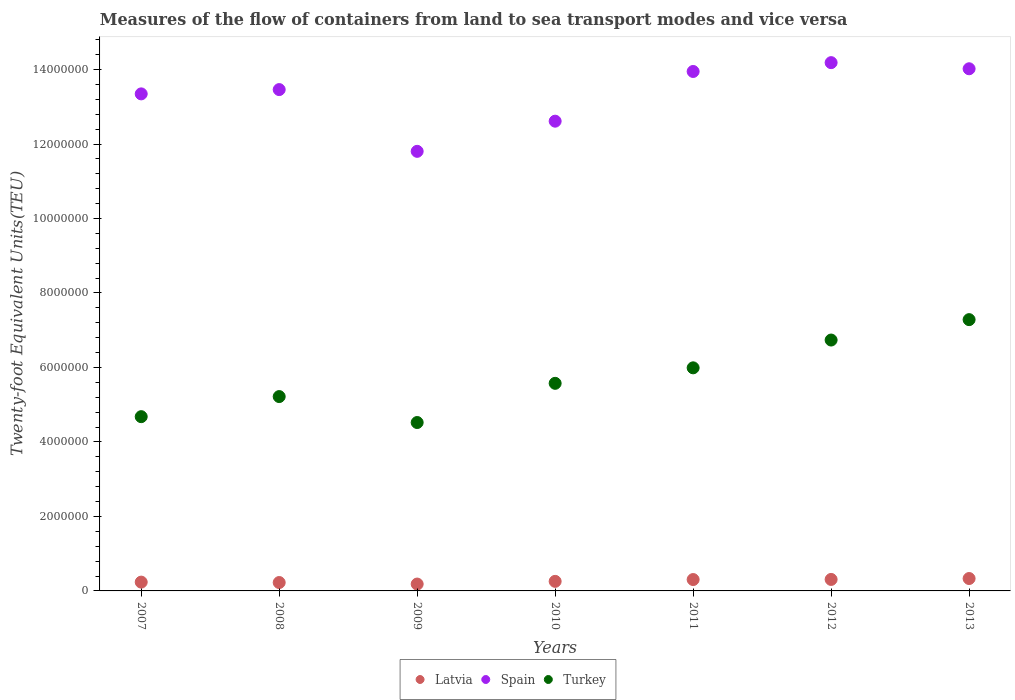What is the container port traffic in Latvia in 2011?
Ensure brevity in your answer.  3.05e+05. Across all years, what is the maximum container port traffic in Latvia?
Ensure brevity in your answer.  3.33e+05. Across all years, what is the minimum container port traffic in Spain?
Provide a succinct answer. 1.18e+07. In which year was the container port traffic in Turkey maximum?
Make the answer very short. 2013. What is the total container port traffic in Latvia in the graph?
Your answer should be compact. 1.85e+06. What is the difference between the container port traffic in Spain in 2007 and that in 2011?
Keep it short and to the point. -6.01e+05. What is the difference between the container port traffic in Turkey in 2009 and the container port traffic in Spain in 2007?
Offer a terse response. -8.82e+06. What is the average container port traffic in Spain per year?
Provide a short and direct response. 1.33e+07. In the year 2009, what is the difference between the container port traffic in Turkey and container port traffic in Latvia?
Keep it short and to the point. 4.34e+06. What is the ratio of the container port traffic in Turkey in 2007 to that in 2010?
Ensure brevity in your answer.  0.84. Is the container port traffic in Spain in 2007 less than that in 2013?
Give a very brief answer. Yes. What is the difference between the highest and the second highest container port traffic in Turkey?
Make the answer very short. 5.48e+05. What is the difference between the highest and the lowest container port traffic in Latvia?
Give a very brief answer. 1.48e+05. Is the sum of the container port traffic in Spain in 2008 and 2010 greater than the maximum container port traffic in Latvia across all years?
Your response must be concise. Yes. Is it the case that in every year, the sum of the container port traffic in Turkey and container port traffic in Latvia  is greater than the container port traffic in Spain?
Your response must be concise. No. Is the container port traffic in Turkey strictly greater than the container port traffic in Latvia over the years?
Your answer should be very brief. Yes. Is the container port traffic in Turkey strictly less than the container port traffic in Spain over the years?
Provide a short and direct response. Yes. How many years are there in the graph?
Ensure brevity in your answer.  7. What is the difference between two consecutive major ticks on the Y-axis?
Ensure brevity in your answer.  2.00e+06. Does the graph contain any zero values?
Your answer should be compact. No. Does the graph contain grids?
Your answer should be very brief. No. Where does the legend appear in the graph?
Keep it short and to the point. Bottom center. How many legend labels are there?
Your answer should be very brief. 3. What is the title of the graph?
Ensure brevity in your answer.  Measures of the flow of containers from land to sea transport modes and vice versa. What is the label or title of the Y-axis?
Offer a very short reply. Twenty-foot Equivalent Units(TEU). What is the Twenty-foot Equivalent Units(TEU) in Latvia in 2007?
Offer a terse response. 2.36e+05. What is the Twenty-foot Equivalent Units(TEU) in Spain in 2007?
Offer a terse response. 1.33e+07. What is the Twenty-foot Equivalent Units(TEU) of Turkey in 2007?
Provide a short and direct response. 4.68e+06. What is the Twenty-foot Equivalent Units(TEU) in Latvia in 2008?
Give a very brief answer. 2.25e+05. What is the Twenty-foot Equivalent Units(TEU) of Spain in 2008?
Provide a short and direct response. 1.35e+07. What is the Twenty-foot Equivalent Units(TEU) in Turkey in 2008?
Offer a terse response. 5.22e+06. What is the Twenty-foot Equivalent Units(TEU) in Latvia in 2009?
Your response must be concise. 1.84e+05. What is the Twenty-foot Equivalent Units(TEU) in Spain in 2009?
Your answer should be compact. 1.18e+07. What is the Twenty-foot Equivalent Units(TEU) in Turkey in 2009?
Your answer should be compact. 4.52e+06. What is the Twenty-foot Equivalent Units(TEU) of Latvia in 2010?
Make the answer very short. 2.57e+05. What is the Twenty-foot Equivalent Units(TEU) in Spain in 2010?
Offer a very short reply. 1.26e+07. What is the Twenty-foot Equivalent Units(TEU) in Turkey in 2010?
Your answer should be compact. 5.57e+06. What is the Twenty-foot Equivalent Units(TEU) in Latvia in 2011?
Offer a very short reply. 3.05e+05. What is the Twenty-foot Equivalent Units(TEU) of Spain in 2011?
Your response must be concise. 1.39e+07. What is the Twenty-foot Equivalent Units(TEU) of Turkey in 2011?
Offer a very short reply. 5.99e+06. What is the Twenty-foot Equivalent Units(TEU) of Latvia in 2012?
Make the answer very short. 3.08e+05. What is the Twenty-foot Equivalent Units(TEU) in Spain in 2012?
Give a very brief answer. 1.42e+07. What is the Twenty-foot Equivalent Units(TEU) of Turkey in 2012?
Your response must be concise. 6.74e+06. What is the Twenty-foot Equivalent Units(TEU) in Latvia in 2013?
Give a very brief answer. 3.33e+05. What is the Twenty-foot Equivalent Units(TEU) in Spain in 2013?
Provide a short and direct response. 1.40e+07. What is the Twenty-foot Equivalent Units(TEU) of Turkey in 2013?
Provide a succinct answer. 7.28e+06. Across all years, what is the maximum Twenty-foot Equivalent Units(TEU) of Latvia?
Your answer should be very brief. 3.33e+05. Across all years, what is the maximum Twenty-foot Equivalent Units(TEU) in Spain?
Provide a short and direct response. 1.42e+07. Across all years, what is the maximum Twenty-foot Equivalent Units(TEU) in Turkey?
Provide a short and direct response. 7.28e+06. Across all years, what is the minimum Twenty-foot Equivalent Units(TEU) of Latvia?
Offer a terse response. 1.84e+05. Across all years, what is the minimum Twenty-foot Equivalent Units(TEU) in Spain?
Ensure brevity in your answer.  1.18e+07. Across all years, what is the minimum Twenty-foot Equivalent Units(TEU) in Turkey?
Ensure brevity in your answer.  4.52e+06. What is the total Twenty-foot Equivalent Units(TEU) in Latvia in the graph?
Your answer should be compact. 1.85e+06. What is the total Twenty-foot Equivalent Units(TEU) of Spain in the graph?
Provide a succinct answer. 9.34e+07. What is the total Twenty-foot Equivalent Units(TEU) in Turkey in the graph?
Your response must be concise. 4.00e+07. What is the difference between the Twenty-foot Equivalent Units(TEU) of Latvia in 2007 and that in 2008?
Offer a terse response. 1.09e+04. What is the difference between the Twenty-foot Equivalent Units(TEU) of Spain in 2007 and that in 2008?
Offer a terse response. -1.15e+05. What is the difference between the Twenty-foot Equivalent Units(TEU) in Turkey in 2007 and that in 2008?
Make the answer very short. -5.39e+05. What is the difference between the Twenty-foot Equivalent Units(TEU) of Latvia in 2007 and that in 2009?
Ensure brevity in your answer.  5.20e+04. What is the difference between the Twenty-foot Equivalent Units(TEU) of Spain in 2007 and that in 2009?
Keep it short and to the point. 1.54e+06. What is the difference between the Twenty-foot Equivalent Units(TEU) in Turkey in 2007 and that in 2009?
Give a very brief answer. 1.57e+05. What is the difference between the Twenty-foot Equivalent Units(TEU) of Latvia in 2007 and that in 2010?
Your answer should be very brief. -2.04e+04. What is the difference between the Twenty-foot Equivalent Units(TEU) in Spain in 2007 and that in 2010?
Your response must be concise. 7.33e+05. What is the difference between the Twenty-foot Equivalent Units(TEU) in Turkey in 2007 and that in 2010?
Your response must be concise. -8.95e+05. What is the difference between the Twenty-foot Equivalent Units(TEU) of Latvia in 2007 and that in 2011?
Ensure brevity in your answer.  -6.90e+04. What is the difference between the Twenty-foot Equivalent Units(TEU) of Spain in 2007 and that in 2011?
Provide a succinct answer. -6.01e+05. What is the difference between the Twenty-foot Equivalent Units(TEU) in Turkey in 2007 and that in 2011?
Offer a terse response. -1.31e+06. What is the difference between the Twenty-foot Equivalent Units(TEU) in Latvia in 2007 and that in 2012?
Ensure brevity in your answer.  -7.21e+04. What is the difference between the Twenty-foot Equivalent Units(TEU) in Spain in 2007 and that in 2012?
Offer a terse response. -8.39e+05. What is the difference between the Twenty-foot Equivalent Units(TEU) in Turkey in 2007 and that in 2012?
Your response must be concise. -2.06e+06. What is the difference between the Twenty-foot Equivalent Units(TEU) in Latvia in 2007 and that in 2013?
Keep it short and to the point. -9.64e+04. What is the difference between the Twenty-foot Equivalent Units(TEU) of Spain in 2007 and that in 2013?
Give a very brief answer. -6.74e+05. What is the difference between the Twenty-foot Equivalent Units(TEU) of Turkey in 2007 and that in 2013?
Your response must be concise. -2.61e+06. What is the difference between the Twenty-foot Equivalent Units(TEU) in Latvia in 2008 and that in 2009?
Provide a succinct answer. 4.11e+04. What is the difference between the Twenty-foot Equivalent Units(TEU) of Spain in 2008 and that in 2009?
Give a very brief answer. 1.66e+06. What is the difference between the Twenty-foot Equivalent Units(TEU) in Turkey in 2008 and that in 2009?
Make the answer very short. 6.97e+05. What is the difference between the Twenty-foot Equivalent Units(TEU) in Latvia in 2008 and that in 2010?
Your answer should be compact. -3.12e+04. What is the difference between the Twenty-foot Equivalent Units(TEU) in Spain in 2008 and that in 2010?
Make the answer very short. 8.48e+05. What is the difference between the Twenty-foot Equivalent Units(TEU) of Turkey in 2008 and that in 2010?
Keep it short and to the point. -3.56e+05. What is the difference between the Twenty-foot Equivalent Units(TEU) in Latvia in 2008 and that in 2011?
Your response must be concise. -7.99e+04. What is the difference between the Twenty-foot Equivalent Units(TEU) in Spain in 2008 and that in 2011?
Your answer should be very brief. -4.86e+05. What is the difference between the Twenty-foot Equivalent Units(TEU) in Turkey in 2008 and that in 2011?
Provide a short and direct response. -7.72e+05. What is the difference between the Twenty-foot Equivalent Units(TEU) in Latvia in 2008 and that in 2012?
Offer a terse response. -8.30e+04. What is the difference between the Twenty-foot Equivalent Units(TEU) of Spain in 2008 and that in 2012?
Offer a terse response. -7.23e+05. What is the difference between the Twenty-foot Equivalent Units(TEU) in Turkey in 2008 and that in 2012?
Ensure brevity in your answer.  -1.52e+06. What is the difference between the Twenty-foot Equivalent Units(TEU) of Latvia in 2008 and that in 2013?
Your answer should be compact. -1.07e+05. What is the difference between the Twenty-foot Equivalent Units(TEU) of Spain in 2008 and that in 2013?
Your answer should be very brief. -5.59e+05. What is the difference between the Twenty-foot Equivalent Units(TEU) in Turkey in 2008 and that in 2013?
Keep it short and to the point. -2.07e+06. What is the difference between the Twenty-foot Equivalent Units(TEU) in Latvia in 2009 and that in 2010?
Provide a short and direct response. -7.23e+04. What is the difference between the Twenty-foot Equivalent Units(TEU) in Spain in 2009 and that in 2010?
Keep it short and to the point. -8.10e+05. What is the difference between the Twenty-foot Equivalent Units(TEU) in Turkey in 2009 and that in 2010?
Give a very brief answer. -1.05e+06. What is the difference between the Twenty-foot Equivalent Units(TEU) of Latvia in 2009 and that in 2011?
Ensure brevity in your answer.  -1.21e+05. What is the difference between the Twenty-foot Equivalent Units(TEU) of Spain in 2009 and that in 2011?
Provide a succinct answer. -2.14e+06. What is the difference between the Twenty-foot Equivalent Units(TEU) of Turkey in 2009 and that in 2011?
Offer a very short reply. -1.47e+06. What is the difference between the Twenty-foot Equivalent Units(TEU) of Latvia in 2009 and that in 2012?
Your answer should be compact. -1.24e+05. What is the difference between the Twenty-foot Equivalent Units(TEU) in Spain in 2009 and that in 2012?
Provide a short and direct response. -2.38e+06. What is the difference between the Twenty-foot Equivalent Units(TEU) in Turkey in 2009 and that in 2012?
Provide a succinct answer. -2.21e+06. What is the difference between the Twenty-foot Equivalent Units(TEU) of Latvia in 2009 and that in 2013?
Keep it short and to the point. -1.48e+05. What is the difference between the Twenty-foot Equivalent Units(TEU) in Spain in 2009 and that in 2013?
Keep it short and to the point. -2.22e+06. What is the difference between the Twenty-foot Equivalent Units(TEU) of Turkey in 2009 and that in 2013?
Ensure brevity in your answer.  -2.76e+06. What is the difference between the Twenty-foot Equivalent Units(TEU) of Latvia in 2010 and that in 2011?
Provide a succinct answer. -4.86e+04. What is the difference between the Twenty-foot Equivalent Units(TEU) of Spain in 2010 and that in 2011?
Your response must be concise. -1.33e+06. What is the difference between the Twenty-foot Equivalent Units(TEU) in Turkey in 2010 and that in 2011?
Offer a terse response. -4.16e+05. What is the difference between the Twenty-foot Equivalent Units(TEU) of Latvia in 2010 and that in 2012?
Make the answer very short. -5.17e+04. What is the difference between the Twenty-foot Equivalent Units(TEU) in Spain in 2010 and that in 2012?
Ensure brevity in your answer.  -1.57e+06. What is the difference between the Twenty-foot Equivalent Units(TEU) of Turkey in 2010 and that in 2012?
Your answer should be very brief. -1.16e+06. What is the difference between the Twenty-foot Equivalent Units(TEU) in Latvia in 2010 and that in 2013?
Provide a succinct answer. -7.61e+04. What is the difference between the Twenty-foot Equivalent Units(TEU) in Spain in 2010 and that in 2013?
Provide a succinct answer. -1.41e+06. What is the difference between the Twenty-foot Equivalent Units(TEU) of Turkey in 2010 and that in 2013?
Make the answer very short. -1.71e+06. What is the difference between the Twenty-foot Equivalent Units(TEU) in Latvia in 2011 and that in 2012?
Keep it short and to the point. -3086.24. What is the difference between the Twenty-foot Equivalent Units(TEU) in Spain in 2011 and that in 2012?
Offer a terse response. -2.37e+05. What is the difference between the Twenty-foot Equivalent Units(TEU) in Turkey in 2011 and that in 2012?
Make the answer very short. -7.46e+05. What is the difference between the Twenty-foot Equivalent Units(TEU) in Latvia in 2011 and that in 2013?
Your answer should be compact. -2.75e+04. What is the difference between the Twenty-foot Equivalent Units(TEU) of Spain in 2011 and that in 2013?
Give a very brief answer. -7.27e+04. What is the difference between the Twenty-foot Equivalent Units(TEU) in Turkey in 2011 and that in 2013?
Provide a short and direct response. -1.29e+06. What is the difference between the Twenty-foot Equivalent Units(TEU) in Latvia in 2012 and that in 2013?
Your answer should be compact. -2.44e+04. What is the difference between the Twenty-foot Equivalent Units(TEU) of Spain in 2012 and that in 2013?
Make the answer very short. 1.65e+05. What is the difference between the Twenty-foot Equivalent Units(TEU) in Turkey in 2012 and that in 2013?
Your response must be concise. -5.48e+05. What is the difference between the Twenty-foot Equivalent Units(TEU) of Latvia in 2007 and the Twenty-foot Equivalent Units(TEU) of Spain in 2008?
Your response must be concise. -1.32e+07. What is the difference between the Twenty-foot Equivalent Units(TEU) of Latvia in 2007 and the Twenty-foot Equivalent Units(TEU) of Turkey in 2008?
Your answer should be very brief. -4.98e+06. What is the difference between the Twenty-foot Equivalent Units(TEU) of Spain in 2007 and the Twenty-foot Equivalent Units(TEU) of Turkey in 2008?
Offer a terse response. 8.13e+06. What is the difference between the Twenty-foot Equivalent Units(TEU) of Latvia in 2007 and the Twenty-foot Equivalent Units(TEU) of Spain in 2009?
Provide a short and direct response. -1.16e+07. What is the difference between the Twenty-foot Equivalent Units(TEU) in Latvia in 2007 and the Twenty-foot Equivalent Units(TEU) in Turkey in 2009?
Ensure brevity in your answer.  -4.29e+06. What is the difference between the Twenty-foot Equivalent Units(TEU) of Spain in 2007 and the Twenty-foot Equivalent Units(TEU) of Turkey in 2009?
Provide a short and direct response. 8.82e+06. What is the difference between the Twenty-foot Equivalent Units(TEU) of Latvia in 2007 and the Twenty-foot Equivalent Units(TEU) of Spain in 2010?
Keep it short and to the point. -1.24e+07. What is the difference between the Twenty-foot Equivalent Units(TEU) in Latvia in 2007 and the Twenty-foot Equivalent Units(TEU) in Turkey in 2010?
Offer a terse response. -5.34e+06. What is the difference between the Twenty-foot Equivalent Units(TEU) in Spain in 2007 and the Twenty-foot Equivalent Units(TEU) in Turkey in 2010?
Make the answer very short. 7.77e+06. What is the difference between the Twenty-foot Equivalent Units(TEU) in Latvia in 2007 and the Twenty-foot Equivalent Units(TEU) in Spain in 2011?
Offer a terse response. -1.37e+07. What is the difference between the Twenty-foot Equivalent Units(TEU) of Latvia in 2007 and the Twenty-foot Equivalent Units(TEU) of Turkey in 2011?
Offer a very short reply. -5.75e+06. What is the difference between the Twenty-foot Equivalent Units(TEU) of Spain in 2007 and the Twenty-foot Equivalent Units(TEU) of Turkey in 2011?
Offer a very short reply. 7.36e+06. What is the difference between the Twenty-foot Equivalent Units(TEU) in Latvia in 2007 and the Twenty-foot Equivalent Units(TEU) in Spain in 2012?
Provide a short and direct response. -1.39e+07. What is the difference between the Twenty-foot Equivalent Units(TEU) of Latvia in 2007 and the Twenty-foot Equivalent Units(TEU) of Turkey in 2012?
Your answer should be very brief. -6.50e+06. What is the difference between the Twenty-foot Equivalent Units(TEU) in Spain in 2007 and the Twenty-foot Equivalent Units(TEU) in Turkey in 2012?
Give a very brief answer. 6.61e+06. What is the difference between the Twenty-foot Equivalent Units(TEU) of Latvia in 2007 and the Twenty-foot Equivalent Units(TEU) of Spain in 2013?
Your answer should be very brief. -1.38e+07. What is the difference between the Twenty-foot Equivalent Units(TEU) in Latvia in 2007 and the Twenty-foot Equivalent Units(TEU) in Turkey in 2013?
Ensure brevity in your answer.  -7.05e+06. What is the difference between the Twenty-foot Equivalent Units(TEU) of Spain in 2007 and the Twenty-foot Equivalent Units(TEU) of Turkey in 2013?
Give a very brief answer. 6.06e+06. What is the difference between the Twenty-foot Equivalent Units(TEU) of Latvia in 2008 and the Twenty-foot Equivalent Units(TEU) of Spain in 2009?
Ensure brevity in your answer.  -1.16e+07. What is the difference between the Twenty-foot Equivalent Units(TEU) in Latvia in 2008 and the Twenty-foot Equivalent Units(TEU) in Turkey in 2009?
Provide a short and direct response. -4.30e+06. What is the difference between the Twenty-foot Equivalent Units(TEU) of Spain in 2008 and the Twenty-foot Equivalent Units(TEU) of Turkey in 2009?
Provide a succinct answer. 8.94e+06. What is the difference between the Twenty-foot Equivalent Units(TEU) in Latvia in 2008 and the Twenty-foot Equivalent Units(TEU) in Spain in 2010?
Offer a terse response. -1.24e+07. What is the difference between the Twenty-foot Equivalent Units(TEU) in Latvia in 2008 and the Twenty-foot Equivalent Units(TEU) in Turkey in 2010?
Provide a short and direct response. -5.35e+06. What is the difference between the Twenty-foot Equivalent Units(TEU) of Spain in 2008 and the Twenty-foot Equivalent Units(TEU) of Turkey in 2010?
Offer a very short reply. 7.89e+06. What is the difference between the Twenty-foot Equivalent Units(TEU) in Latvia in 2008 and the Twenty-foot Equivalent Units(TEU) in Spain in 2011?
Ensure brevity in your answer.  -1.37e+07. What is the difference between the Twenty-foot Equivalent Units(TEU) in Latvia in 2008 and the Twenty-foot Equivalent Units(TEU) in Turkey in 2011?
Make the answer very short. -5.76e+06. What is the difference between the Twenty-foot Equivalent Units(TEU) in Spain in 2008 and the Twenty-foot Equivalent Units(TEU) in Turkey in 2011?
Give a very brief answer. 7.47e+06. What is the difference between the Twenty-foot Equivalent Units(TEU) in Latvia in 2008 and the Twenty-foot Equivalent Units(TEU) in Spain in 2012?
Provide a succinct answer. -1.40e+07. What is the difference between the Twenty-foot Equivalent Units(TEU) of Latvia in 2008 and the Twenty-foot Equivalent Units(TEU) of Turkey in 2012?
Your answer should be very brief. -6.51e+06. What is the difference between the Twenty-foot Equivalent Units(TEU) of Spain in 2008 and the Twenty-foot Equivalent Units(TEU) of Turkey in 2012?
Your answer should be compact. 6.72e+06. What is the difference between the Twenty-foot Equivalent Units(TEU) of Latvia in 2008 and the Twenty-foot Equivalent Units(TEU) of Spain in 2013?
Make the answer very short. -1.38e+07. What is the difference between the Twenty-foot Equivalent Units(TEU) of Latvia in 2008 and the Twenty-foot Equivalent Units(TEU) of Turkey in 2013?
Provide a short and direct response. -7.06e+06. What is the difference between the Twenty-foot Equivalent Units(TEU) in Spain in 2008 and the Twenty-foot Equivalent Units(TEU) in Turkey in 2013?
Keep it short and to the point. 6.18e+06. What is the difference between the Twenty-foot Equivalent Units(TEU) in Latvia in 2009 and the Twenty-foot Equivalent Units(TEU) in Spain in 2010?
Offer a terse response. -1.24e+07. What is the difference between the Twenty-foot Equivalent Units(TEU) of Latvia in 2009 and the Twenty-foot Equivalent Units(TEU) of Turkey in 2010?
Make the answer very short. -5.39e+06. What is the difference between the Twenty-foot Equivalent Units(TEU) in Spain in 2009 and the Twenty-foot Equivalent Units(TEU) in Turkey in 2010?
Give a very brief answer. 6.23e+06. What is the difference between the Twenty-foot Equivalent Units(TEU) of Latvia in 2009 and the Twenty-foot Equivalent Units(TEU) of Spain in 2011?
Your answer should be very brief. -1.38e+07. What is the difference between the Twenty-foot Equivalent Units(TEU) of Latvia in 2009 and the Twenty-foot Equivalent Units(TEU) of Turkey in 2011?
Your answer should be compact. -5.81e+06. What is the difference between the Twenty-foot Equivalent Units(TEU) in Spain in 2009 and the Twenty-foot Equivalent Units(TEU) in Turkey in 2011?
Give a very brief answer. 5.81e+06. What is the difference between the Twenty-foot Equivalent Units(TEU) in Latvia in 2009 and the Twenty-foot Equivalent Units(TEU) in Spain in 2012?
Keep it short and to the point. -1.40e+07. What is the difference between the Twenty-foot Equivalent Units(TEU) of Latvia in 2009 and the Twenty-foot Equivalent Units(TEU) of Turkey in 2012?
Make the answer very short. -6.55e+06. What is the difference between the Twenty-foot Equivalent Units(TEU) in Spain in 2009 and the Twenty-foot Equivalent Units(TEU) in Turkey in 2012?
Keep it short and to the point. 5.07e+06. What is the difference between the Twenty-foot Equivalent Units(TEU) of Latvia in 2009 and the Twenty-foot Equivalent Units(TEU) of Spain in 2013?
Your answer should be compact. -1.38e+07. What is the difference between the Twenty-foot Equivalent Units(TEU) of Latvia in 2009 and the Twenty-foot Equivalent Units(TEU) of Turkey in 2013?
Offer a very short reply. -7.10e+06. What is the difference between the Twenty-foot Equivalent Units(TEU) in Spain in 2009 and the Twenty-foot Equivalent Units(TEU) in Turkey in 2013?
Give a very brief answer. 4.52e+06. What is the difference between the Twenty-foot Equivalent Units(TEU) in Latvia in 2010 and the Twenty-foot Equivalent Units(TEU) in Spain in 2011?
Ensure brevity in your answer.  -1.37e+07. What is the difference between the Twenty-foot Equivalent Units(TEU) in Latvia in 2010 and the Twenty-foot Equivalent Units(TEU) in Turkey in 2011?
Offer a terse response. -5.73e+06. What is the difference between the Twenty-foot Equivalent Units(TEU) of Spain in 2010 and the Twenty-foot Equivalent Units(TEU) of Turkey in 2011?
Offer a very short reply. 6.62e+06. What is the difference between the Twenty-foot Equivalent Units(TEU) in Latvia in 2010 and the Twenty-foot Equivalent Units(TEU) in Spain in 2012?
Ensure brevity in your answer.  -1.39e+07. What is the difference between the Twenty-foot Equivalent Units(TEU) of Latvia in 2010 and the Twenty-foot Equivalent Units(TEU) of Turkey in 2012?
Your response must be concise. -6.48e+06. What is the difference between the Twenty-foot Equivalent Units(TEU) in Spain in 2010 and the Twenty-foot Equivalent Units(TEU) in Turkey in 2012?
Provide a short and direct response. 5.88e+06. What is the difference between the Twenty-foot Equivalent Units(TEU) in Latvia in 2010 and the Twenty-foot Equivalent Units(TEU) in Spain in 2013?
Make the answer very short. -1.38e+07. What is the difference between the Twenty-foot Equivalent Units(TEU) of Latvia in 2010 and the Twenty-foot Equivalent Units(TEU) of Turkey in 2013?
Provide a short and direct response. -7.03e+06. What is the difference between the Twenty-foot Equivalent Units(TEU) of Spain in 2010 and the Twenty-foot Equivalent Units(TEU) of Turkey in 2013?
Provide a short and direct response. 5.33e+06. What is the difference between the Twenty-foot Equivalent Units(TEU) of Latvia in 2011 and the Twenty-foot Equivalent Units(TEU) of Spain in 2012?
Ensure brevity in your answer.  -1.39e+07. What is the difference between the Twenty-foot Equivalent Units(TEU) in Latvia in 2011 and the Twenty-foot Equivalent Units(TEU) in Turkey in 2012?
Offer a very short reply. -6.43e+06. What is the difference between the Twenty-foot Equivalent Units(TEU) of Spain in 2011 and the Twenty-foot Equivalent Units(TEU) of Turkey in 2012?
Provide a succinct answer. 7.21e+06. What is the difference between the Twenty-foot Equivalent Units(TEU) in Latvia in 2011 and the Twenty-foot Equivalent Units(TEU) in Spain in 2013?
Your answer should be very brief. -1.37e+07. What is the difference between the Twenty-foot Equivalent Units(TEU) in Latvia in 2011 and the Twenty-foot Equivalent Units(TEU) in Turkey in 2013?
Provide a succinct answer. -6.98e+06. What is the difference between the Twenty-foot Equivalent Units(TEU) of Spain in 2011 and the Twenty-foot Equivalent Units(TEU) of Turkey in 2013?
Give a very brief answer. 6.66e+06. What is the difference between the Twenty-foot Equivalent Units(TEU) of Latvia in 2012 and the Twenty-foot Equivalent Units(TEU) of Spain in 2013?
Offer a very short reply. -1.37e+07. What is the difference between the Twenty-foot Equivalent Units(TEU) of Latvia in 2012 and the Twenty-foot Equivalent Units(TEU) of Turkey in 2013?
Your response must be concise. -6.98e+06. What is the difference between the Twenty-foot Equivalent Units(TEU) of Spain in 2012 and the Twenty-foot Equivalent Units(TEU) of Turkey in 2013?
Offer a very short reply. 6.90e+06. What is the average Twenty-foot Equivalent Units(TEU) in Latvia per year?
Provide a succinct answer. 2.64e+05. What is the average Twenty-foot Equivalent Units(TEU) of Spain per year?
Provide a succinct answer. 1.33e+07. What is the average Twenty-foot Equivalent Units(TEU) in Turkey per year?
Provide a succinct answer. 5.71e+06. In the year 2007, what is the difference between the Twenty-foot Equivalent Units(TEU) in Latvia and Twenty-foot Equivalent Units(TEU) in Spain?
Make the answer very short. -1.31e+07. In the year 2007, what is the difference between the Twenty-foot Equivalent Units(TEU) in Latvia and Twenty-foot Equivalent Units(TEU) in Turkey?
Keep it short and to the point. -4.44e+06. In the year 2007, what is the difference between the Twenty-foot Equivalent Units(TEU) of Spain and Twenty-foot Equivalent Units(TEU) of Turkey?
Provide a succinct answer. 8.67e+06. In the year 2008, what is the difference between the Twenty-foot Equivalent Units(TEU) in Latvia and Twenty-foot Equivalent Units(TEU) in Spain?
Provide a short and direct response. -1.32e+07. In the year 2008, what is the difference between the Twenty-foot Equivalent Units(TEU) of Latvia and Twenty-foot Equivalent Units(TEU) of Turkey?
Ensure brevity in your answer.  -4.99e+06. In the year 2008, what is the difference between the Twenty-foot Equivalent Units(TEU) in Spain and Twenty-foot Equivalent Units(TEU) in Turkey?
Your response must be concise. 8.24e+06. In the year 2009, what is the difference between the Twenty-foot Equivalent Units(TEU) in Latvia and Twenty-foot Equivalent Units(TEU) in Spain?
Offer a terse response. -1.16e+07. In the year 2009, what is the difference between the Twenty-foot Equivalent Units(TEU) in Latvia and Twenty-foot Equivalent Units(TEU) in Turkey?
Your answer should be very brief. -4.34e+06. In the year 2009, what is the difference between the Twenty-foot Equivalent Units(TEU) in Spain and Twenty-foot Equivalent Units(TEU) in Turkey?
Provide a succinct answer. 7.28e+06. In the year 2010, what is the difference between the Twenty-foot Equivalent Units(TEU) of Latvia and Twenty-foot Equivalent Units(TEU) of Spain?
Your answer should be very brief. -1.24e+07. In the year 2010, what is the difference between the Twenty-foot Equivalent Units(TEU) in Latvia and Twenty-foot Equivalent Units(TEU) in Turkey?
Your response must be concise. -5.32e+06. In the year 2010, what is the difference between the Twenty-foot Equivalent Units(TEU) of Spain and Twenty-foot Equivalent Units(TEU) of Turkey?
Make the answer very short. 7.04e+06. In the year 2011, what is the difference between the Twenty-foot Equivalent Units(TEU) in Latvia and Twenty-foot Equivalent Units(TEU) in Spain?
Make the answer very short. -1.36e+07. In the year 2011, what is the difference between the Twenty-foot Equivalent Units(TEU) in Latvia and Twenty-foot Equivalent Units(TEU) in Turkey?
Your answer should be very brief. -5.68e+06. In the year 2011, what is the difference between the Twenty-foot Equivalent Units(TEU) of Spain and Twenty-foot Equivalent Units(TEU) of Turkey?
Offer a terse response. 7.96e+06. In the year 2012, what is the difference between the Twenty-foot Equivalent Units(TEU) in Latvia and Twenty-foot Equivalent Units(TEU) in Spain?
Give a very brief answer. -1.39e+07. In the year 2012, what is the difference between the Twenty-foot Equivalent Units(TEU) in Latvia and Twenty-foot Equivalent Units(TEU) in Turkey?
Offer a very short reply. -6.43e+06. In the year 2012, what is the difference between the Twenty-foot Equivalent Units(TEU) of Spain and Twenty-foot Equivalent Units(TEU) of Turkey?
Ensure brevity in your answer.  7.45e+06. In the year 2013, what is the difference between the Twenty-foot Equivalent Units(TEU) in Latvia and Twenty-foot Equivalent Units(TEU) in Spain?
Give a very brief answer. -1.37e+07. In the year 2013, what is the difference between the Twenty-foot Equivalent Units(TEU) of Latvia and Twenty-foot Equivalent Units(TEU) of Turkey?
Offer a very short reply. -6.95e+06. In the year 2013, what is the difference between the Twenty-foot Equivalent Units(TEU) in Spain and Twenty-foot Equivalent Units(TEU) in Turkey?
Your response must be concise. 6.74e+06. What is the ratio of the Twenty-foot Equivalent Units(TEU) in Latvia in 2007 to that in 2008?
Your answer should be very brief. 1.05. What is the ratio of the Twenty-foot Equivalent Units(TEU) of Spain in 2007 to that in 2008?
Provide a short and direct response. 0.99. What is the ratio of the Twenty-foot Equivalent Units(TEU) of Turkey in 2007 to that in 2008?
Your answer should be compact. 0.9. What is the ratio of the Twenty-foot Equivalent Units(TEU) in Latvia in 2007 to that in 2009?
Your answer should be compact. 1.28. What is the ratio of the Twenty-foot Equivalent Units(TEU) of Spain in 2007 to that in 2009?
Offer a terse response. 1.13. What is the ratio of the Twenty-foot Equivalent Units(TEU) in Turkey in 2007 to that in 2009?
Keep it short and to the point. 1.03. What is the ratio of the Twenty-foot Equivalent Units(TEU) in Latvia in 2007 to that in 2010?
Provide a succinct answer. 0.92. What is the ratio of the Twenty-foot Equivalent Units(TEU) of Spain in 2007 to that in 2010?
Give a very brief answer. 1.06. What is the ratio of the Twenty-foot Equivalent Units(TEU) in Turkey in 2007 to that in 2010?
Offer a very short reply. 0.84. What is the ratio of the Twenty-foot Equivalent Units(TEU) of Latvia in 2007 to that in 2011?
Give a very brief answer. 0.77. What is the ratio of the Twenty-foot Equivalent Units(TEU) in Spain in 2007 to that in 2011?
Your answer should be very brief. 0.96. What is the ratio of the Twenty-foot Equivalent Units(TEU) of Turkey in 2007 to that in 2011?
Keep it short and to the point. 0.78. What is the ratio of the Twenty-foot Equivalent Units(TEU) of Latvia in 2007 to that in 2012?
Ensure brevity in your answer.  0.77. What is the ratio of the Twenty-foot Equivalent Units(TEU) in Spain in 2007 to that in 2012?
Offer a very short reply. 0.94. What is the ratio of the Twenty-foot Equivalent Units(TEU) in Turkey in 2007 to that in 2012?
Ensure brevity in your answer.  0.69. What is the ratio of the Twenty-foot Equivalent Units(TEU) in Latvia in 2007 to that in 2013?
Your answer should be compact. 0.71. What is the ratio of the Twenty-foot Equivalent Units(TEU) in Spain in 2007 to that in 2013?
Your answer should be compact. 0.95. What is the ratio of the Twenty-foot Equivalent Units(TEU) in Turkey in 2007 to that in 2013?
Your answer should be compact. 0.64. What is the ratio of the Twenty-foot Equivalent Units(TEU) of Latvia in 2008 to that in 2009?
Your answer should be compact. 1.22. What is the ratio of the Twenty-foot Equivalent Units(TEU) of Spain in 2008 to that in 2009?
Provide a succinct answer. 1.14. What is the ratio of the Twenty-foot Equivalent Units(TEU) in Turkey in 2008 to that in 2009?
Provide a succinct answer. 1.15. What is the ratio of the Twenty-foot Equivalent Units(TEU) of Latvia in 2008 to that in 2010?
Offer a terse response. 0.88. What is the ratio of the Twenty-foot Equivalent Units(TEU) in Spain in 2008 to that in 2010?
Make the answer very short. 1.07. What is the ratio of the Twenty-foot Equivalent Units(TEU) of Turkey in 2008 to that in 2010?
Ensure brevity in your answer.  0.94. What is the ratio of the Twenty-foot Equivalent Units(TEU) of Latvia in 2008 to that in 2011?
Keep it short and to the point. 0.74. What is the ratio of the Twenty-foot Equivalent Units(TEU) in Spain in 2008 to that in 2011?
Offer a very short reply. 0.97. What is the ratio of the Twenty-foot Equivalent Units(TEU) of Turkey in 2008 to that in 2011?
Offer a terse response. 0.87. What is the ratio of the Twenty-foot Equivalent Units(TEU) in Latvia in 2008 to that in 2012?
Provide a short and direct response. 0.73. What is the ratio of the Twenty-foot Equivalent Units(TEU) in Spain in 2008 to that in 2012?
Offer a very short reply. 0.95. What is the ratio of the Twenty-foot Equivalent Units(TEU) of Turkey in 2008 to that in 2012?
Keep it short and to the point. 0.77. What is the ratio of the Twenty-foot Equivalent Units(TEU) in Latvia in 2008 to that in 2013?
Ensure brevity in your answer.  0.68. What is the ratio of the Twenty-foot Equivalent Units(TEU) of Spain in 2008 to that in 2013?
Your response must be concise. 0.96. What is the ratio of the Twenty-foot Equivalent Units(TEU) of Turkey in 2008 to that in 2013?
Your answer should be very brief. 0.72. What is the ratio of the Twenty-foot Equivalent Units(TEU) of Latvia in 2009 to that in 2010?
Offer a terse response. 0.72. What is the ratio of the Twenty-foot Equivalent Units(TEU) in Spain in 2009 to that in 2010?
Ensure brevity in your answer.  0.94. What is the ratio of the Twenty-foot Equivalent Units(TEU) of Turkey in 2009 to that in 2010?
Your response must be concise. 0.81. What is the ratio of the Twenty-foot Equivalent Units(TEU) in Latvia in 2009 to that in 2011?
Provide a succinct answer. 0.6. What is the ratio of the Twenty-foot Equivalent Units(TEU) of Spain in 2009 to that in 2011?
Your answer should be very brief. 0.85. What is the ratio of the Twenty-foot Equivalent Units(TEU) of Turkey in 2009 to that in 2011?
Make the answer very short. 0.75. What is the ratio of the Twenty-foot Equivalent Units(TEU) of Latvia in 2009 to that in 2012?
Offer a very short reply. 0.6. What is the ratio of the Twenty-foot Equivalent Units(TEU) of Spain in 2009 to that in 2012?
Your response must be concise. 0.83. What is the ratio of the Twenty-foot Equivalent Units(TEU) in Turkey in 2009 to that in 2012?
Your answer should be compact. 0.67. What is the ratio of the Twenty-foot Equivalent Units(TEU) of Latvia in 2009 to that in 2013?
Give a very brief answer. 0.55. What is the ratio of the Twenty-foot Equivalent Units(TEU) of Spain in 2009 to that in 2013?
Give a very brief answer. 0.84. What is the ratio of the Twenty-foot Equivalent Units(TEU) in Turkey in 2009 to that in 2013?
Your answer should be compact. 0.62. What is the ratio of the Twenty-foot Equivalent Units(TEU) in Latvia in 2010 to that in 2011?
Provide a short and direct response. 0.84. What is the ratio of the Twenty-foot Equivalent Units(TEU) in Spain in 2010 to that in 2011?
Provide a short and direct response. 0.9. What is the ratio of the Twenty-foot Equivalent Units(TEU) of Turkey in 2010 to that in 2011?
Provide a short and direct response. 0.93. What is the ratio of the Twenty-foot Equivalent Units(TEU) in Latvia in 2010 to that in 2012?
Give a very brief answer. 0.83. What is the ratio of the Twenty-foot Equivalent Units(TEU) of Spain in 2010 to that in 2012?
Offer a terse response. 0.89. What is the ratio of the Twenty-foot Equivalent Units(TEU) of Turkey in 2010 to that in 2012?
Keep it short and to the point. 0.83. What is the ratio of the Twenty-foot Equivalent Units(TEU) in Latvia in 2010 to that in 2013?
Provide a short and direct response. 0.77. What is the ratio of the Twenty-foot Equivalent Units(TEU) of Spain in 2010 to that in 2013?
Make the answer very short. 0.9. What is the ratio of the Twenty-foot Equivalent Units(TEU) of Turkey in 2010 to that in 2013?
Your response must be concise. 0.77. What is the ratio of the Twenty-foot Equivalent Units(TEU) in Spain in 2011 to that in 2012?
Ensure brevity in your answer.  0.98. What is the ratio of the Twenty-foot Equivalent Units(TEU) in Turkey in 2011 to that in 2012?
Your response must be concise. 0.89. What is the ratio of the Twenty-foot Equivalent Units(TEU) in Latvia in 2011 to that in 2013?
Make the answer very short. 0.92. What is the ratio of the Twenty-foot Equivalent Units(TEU) in Turkey in 2011 to that in 2013?
Ensure brevity in your answer.  0.82. What is the ratio of the Twenty-foot Equivalent Units(TEU) of Latvia in 2012 to that in 2013?
Offer a very short reply. 0.93. What is the ratio of the Twenty-foot Equivalent Units(TEU) in Spain in 2012 to that in 2013?
Your answer should be compact. 1.01. What is the ratio of the Twenty-foot Equivalent Units(TEU) in Turkey in 2012 to that in 2013?
Keep it short and to the point. 0.92. What is the difference between the highest and the second highest Twenty-foot Equivalent Units(TEU) of Latvia?
Your answer should be very brief. 2.44e+04. What is the difference between the highest and the second highest Twenty-foot Equivalent Units(TEU) of Spain?
Your answer should be compact. 1.65e+05. What is the difference between the highest and the second highest Twenty-foot Equivalent Units(TEU) of Turkey?
Keep it short and to the point. 5.48e+05. What is the difference between the highest and the lowest Twenty-foot Equivalent Units(TEU) of Latvia?
Give a very brief answer. 1.48e+05. What is the difference between the highest and the lowest Twenty-foot Equivalent Units(TEU) of Spain?
Keep it short and to the point. 2.38e+06. What is the difference between the highest and the lowest Twenty-foot Equivalent Units(TEU) of Turkey?
Your answer should be very brief. 2.76e+06. 